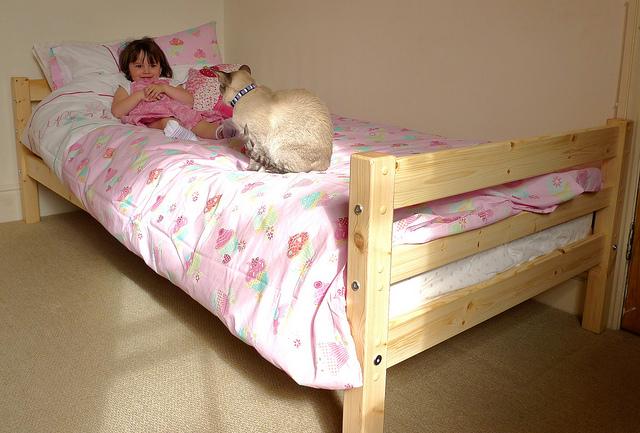What animal is on the bed?
Short answer required. Cat. Are the sheets blue?
Be succinct. No. Is this a king size bed?
Answer briefly. No. 